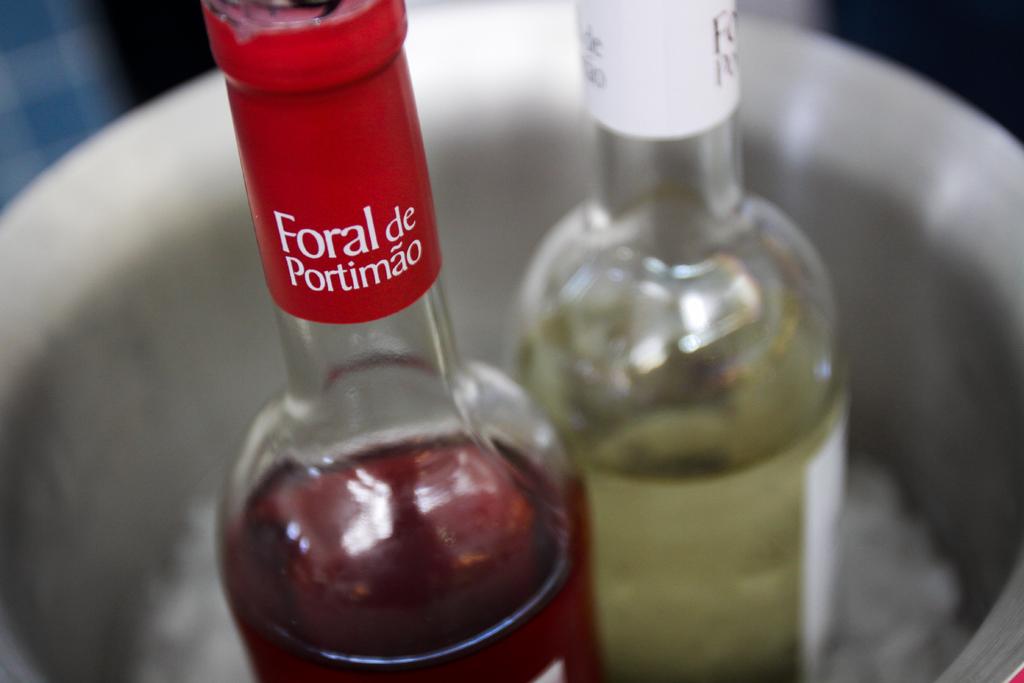Who makes the red bottle?
Offer a very short reply. Foral de portimao. What word can you spell with the first three letters of the first word?
Your answer should be compact. For. 